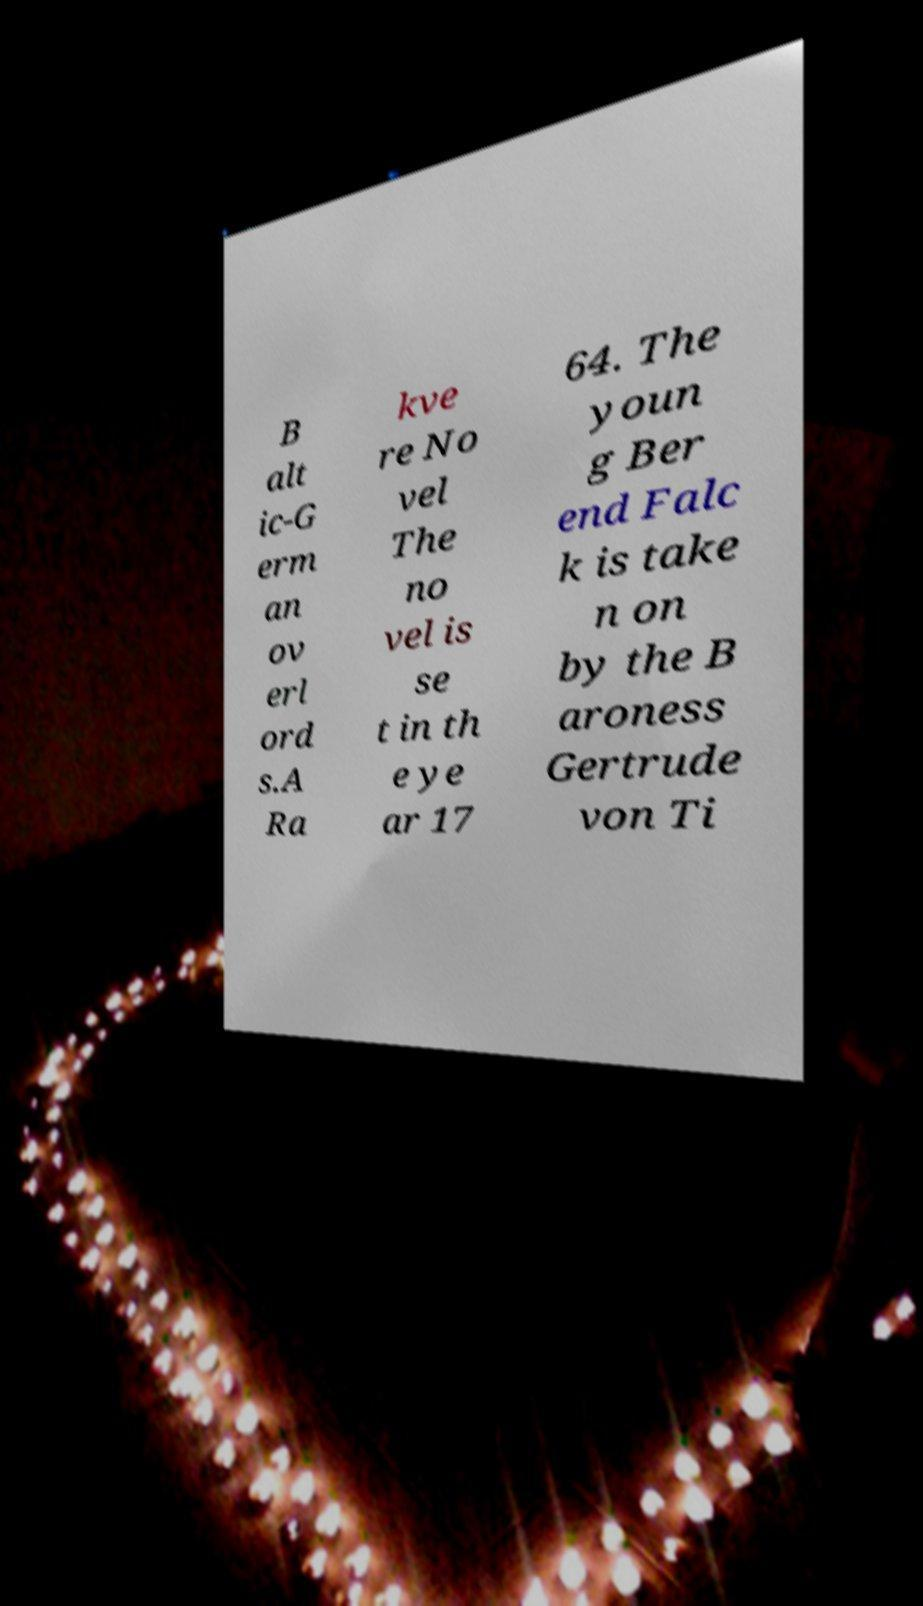Please identify and transcribe the text found in this image. B alt ic-G erm an ov erl ord s.A Ra kve re No vel The no vel is se t in th e ye ar 17 64. The youn g Ber end Falc k is take n on by the B aroness Gertrude von Ti 